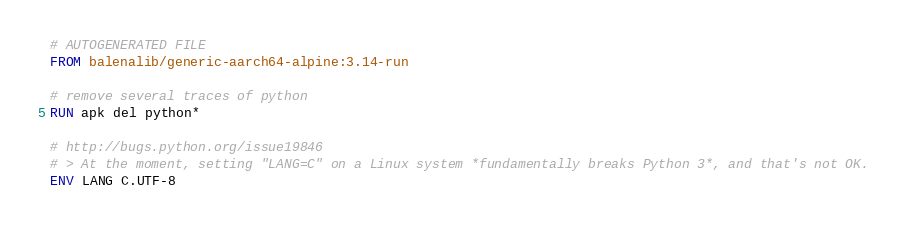Convert code to text. <code><loc_0><loc_0><loc_500><loc_500><_Dockerfile_># AUTOGENERATED FILE
FROM balenalib/generic-aarch64-alpine:3.14-run

# remove several traces of python
RUN apk del python*

# http://bugs.python.org/issue19846
# > At the moment, setting "LANG=C" on a Linux system *fundamentally breaks Python 3*, and that's not OK.
ENV LANG C.UTF-8
</code> 